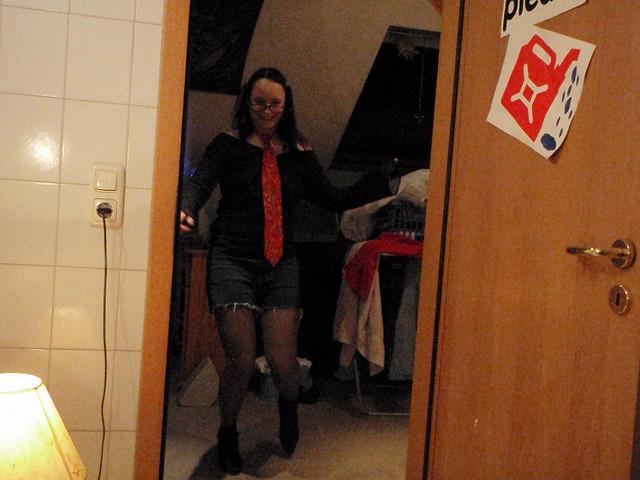What item of clothing does she wear that is traditionally worn by a male?
Write a very short answer. Tie. Is the lady wearing pants?
Give a very brief answer. No. Is the door opened?
Answer briefly. Yes. 